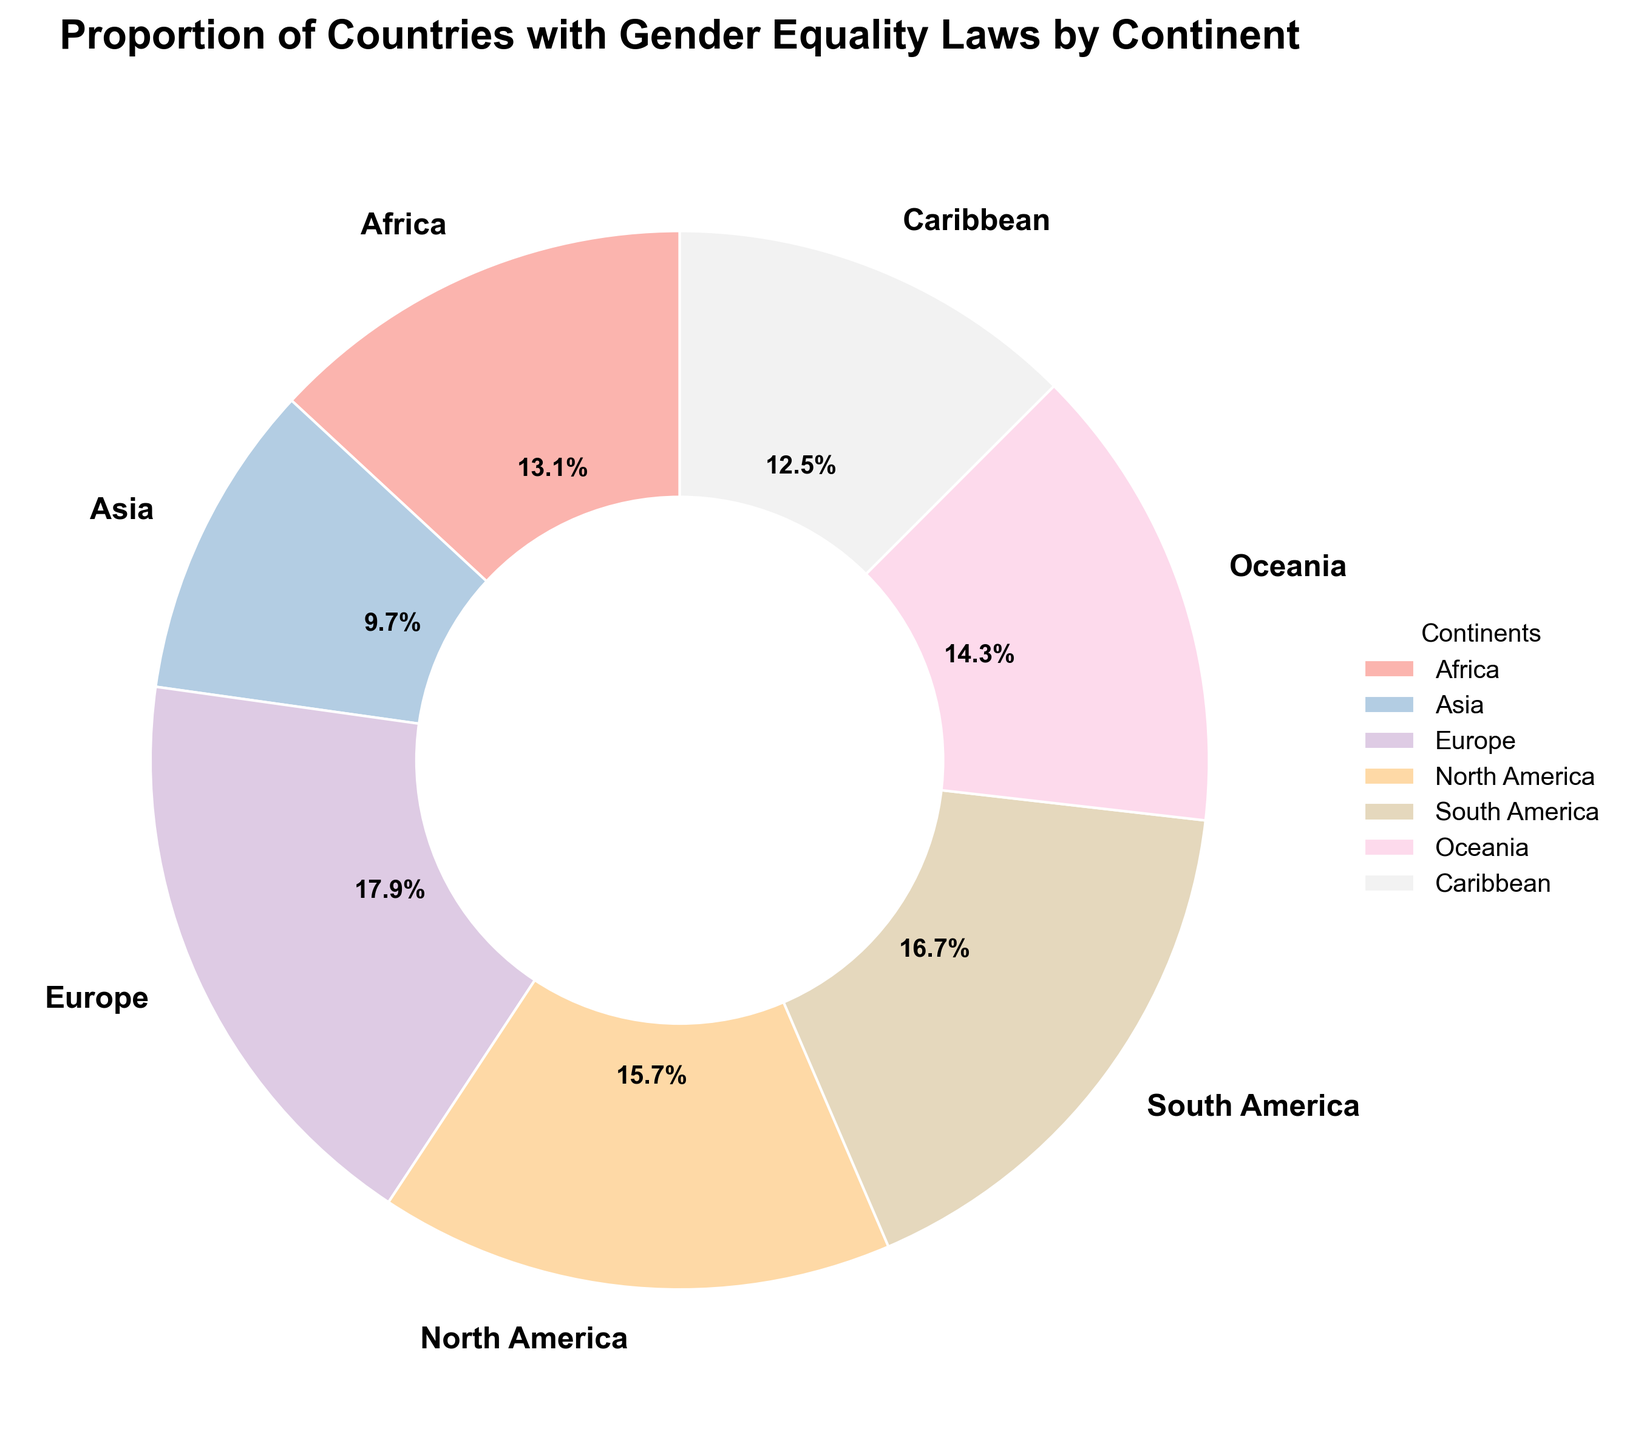Which continent has the highest proportion of countries with gender equality laws? We can determine this by looking at the continent with the largest slice in the pie chart. The largest slice belongs to Europe.
Answer: Europe Which continent has the lowest proportion of countries with gender equality laws? By observing the pie chart, the smallest slice represents Asia.
Answer: Asia If you combine the proportions of Africa and Oceania, is the combined proportion more or less than that of Europe? To answer this, add the proportions of Africa (0.65) and Oceania (0.71), which equals 0.65 + 0.71 = 1.36. This is more than Europe’s proportion of 0.89.
Answer: More How does the proportion of countries with gender equality laws in South America compare to that in North America? From the pie chart, compare the sizes of the slices for South America and North America. South America has a proportion of 0.83 while North America has 0.78, so South America has a higher proportion.
Answer: South America has a higher proportion How many continents have a proportion of countries with gender equality laws that are greater than 0.7? Look at each slice and identify the continents with more than 0.7. These are Africa, Europe, North America, South America, and Oceania. There are five such continents.
Answer: Five Which continents have nearly equal proportions of countries with gender equality laws? By visually comparing the slices, we see that the proportions for North America (0.78) and Oceania (0.71) are relatively close to each other, as well as Africa (0.65) and Caribbean (0.62).
Answer: North America and Oceania; Africa and Caribbean What are the combined proportions of the continents with the smallest and second smallest proportions of gender equality laws? The smallest proportion is Asia (0.48) and the second smallest is Caribbean (0.62). Their combined proportion is 0.48 + 0.62 = 1.10.
Answer: 1.10 If a continent had a slice color that appeared pastel blue, which continent would it most likely be? By looking at the visual colors in the pie chart, we associate pastel blue with Europe which has one of the biggest slices.
Answer: Europe What is the average proportion of countries with gender equality laws among all continents? To find the average proportion, add all proportions and divide by the number of continents: (0.65 + 0.48 + 0.89 + 0.78 + 0.83 + 0.71 + 0.62) / 7 = 4.96 / 7 ≈ 0.71.
Answer: 0.71 